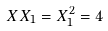<formula> <loc_0><loc_0><loc_500><loc_500>X X _ { 1 } = X _ { 1 } ^ { 2 } = 4</formula> 